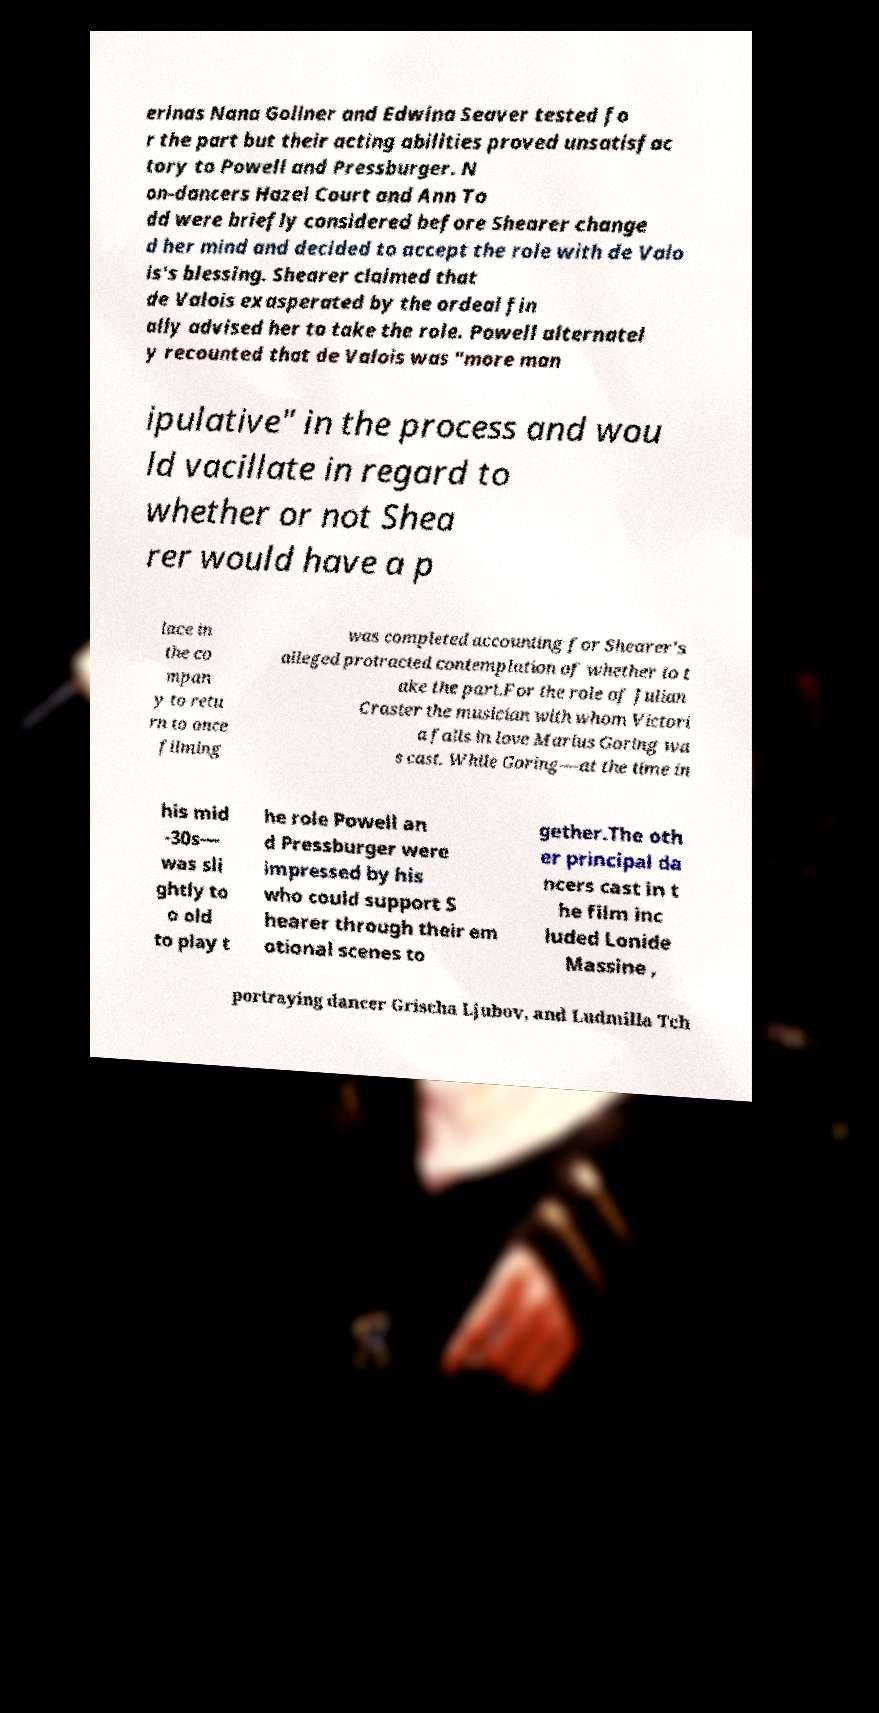Could you assist in decoding the text presented in this image and type it out clearly? erinas Nana Gollner and Edwina Seaver tested fo r the part but their acting abilities proved unsatisfac tory to Powell and Pressburger. N on-dancers Hazel Court and Ann To dd were briefly considered before Shearer change d her mind and decided to accept the role with de Valo is's blessing. Shearer claimed that de Valois exasperated by the ordeal fin ally advised her to take the role. Powell alternatel y recounted that de Valois was "more man ipulative" in the process and wou ld vacillate in regard to whether or not Shea rer would have a p lace in the co mpan y to retu rn to once filming was completed accounting for Shearer's alleged protracted contemplation of whether to t ake the part.For the role of Julian Craster the musician with whom Victori a falls in love Marius Goring wa s cast. While Goring—at the time in his mid -30s— was sli ghtly to o old to play t he role Powell an d Pressburger were impressed by his who could support S hearer through their em otional scenes to gether.The oth er principal da ncers cast in t he film inc luded Lonide Massine , portraying dancer Grischa Ljubov, and Ludmilla Tch 